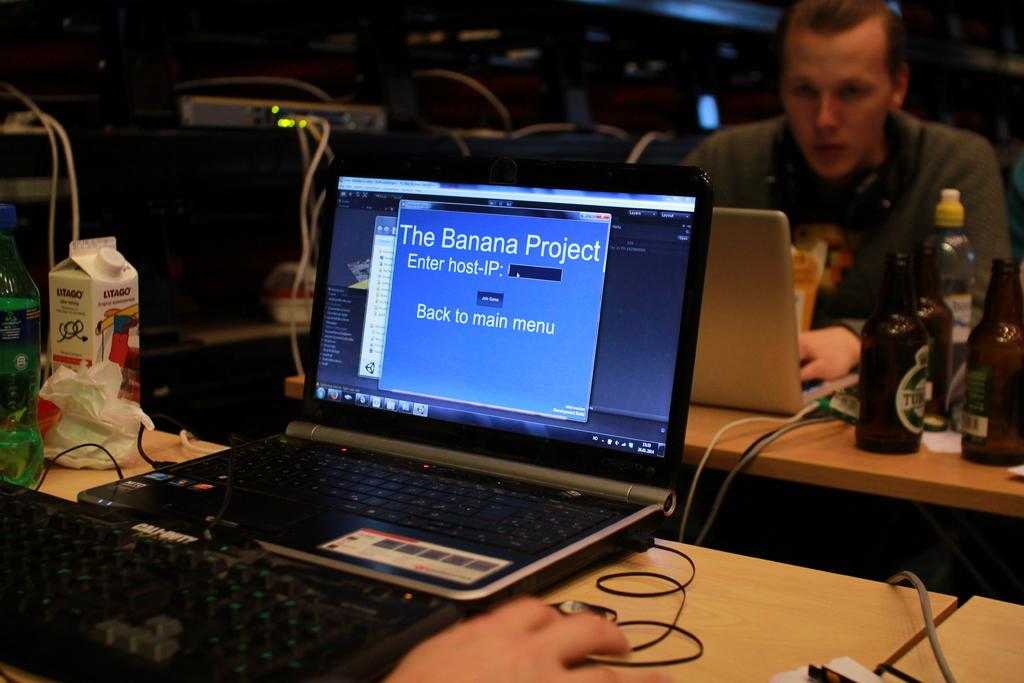<image>
Give a short and clear explanation of the subsequent image. A laptop running The Banana Project prompting for the host-IP. 